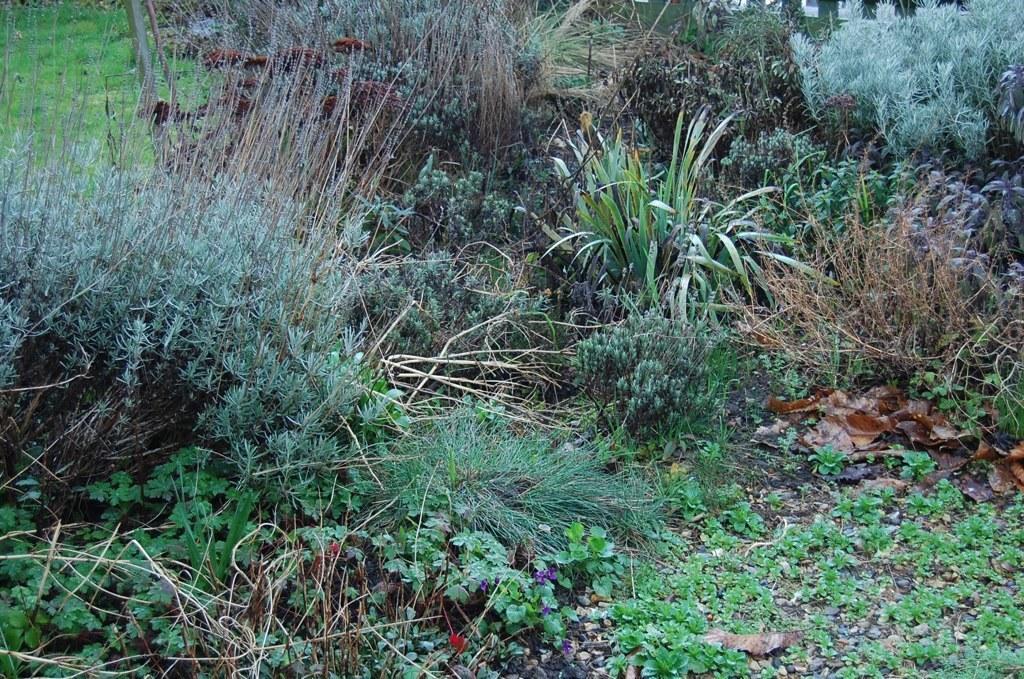Describe this image in one or two sentences. In the picture we can see a surface with small plant saplings, grass plants, and other different kinds of plants. 